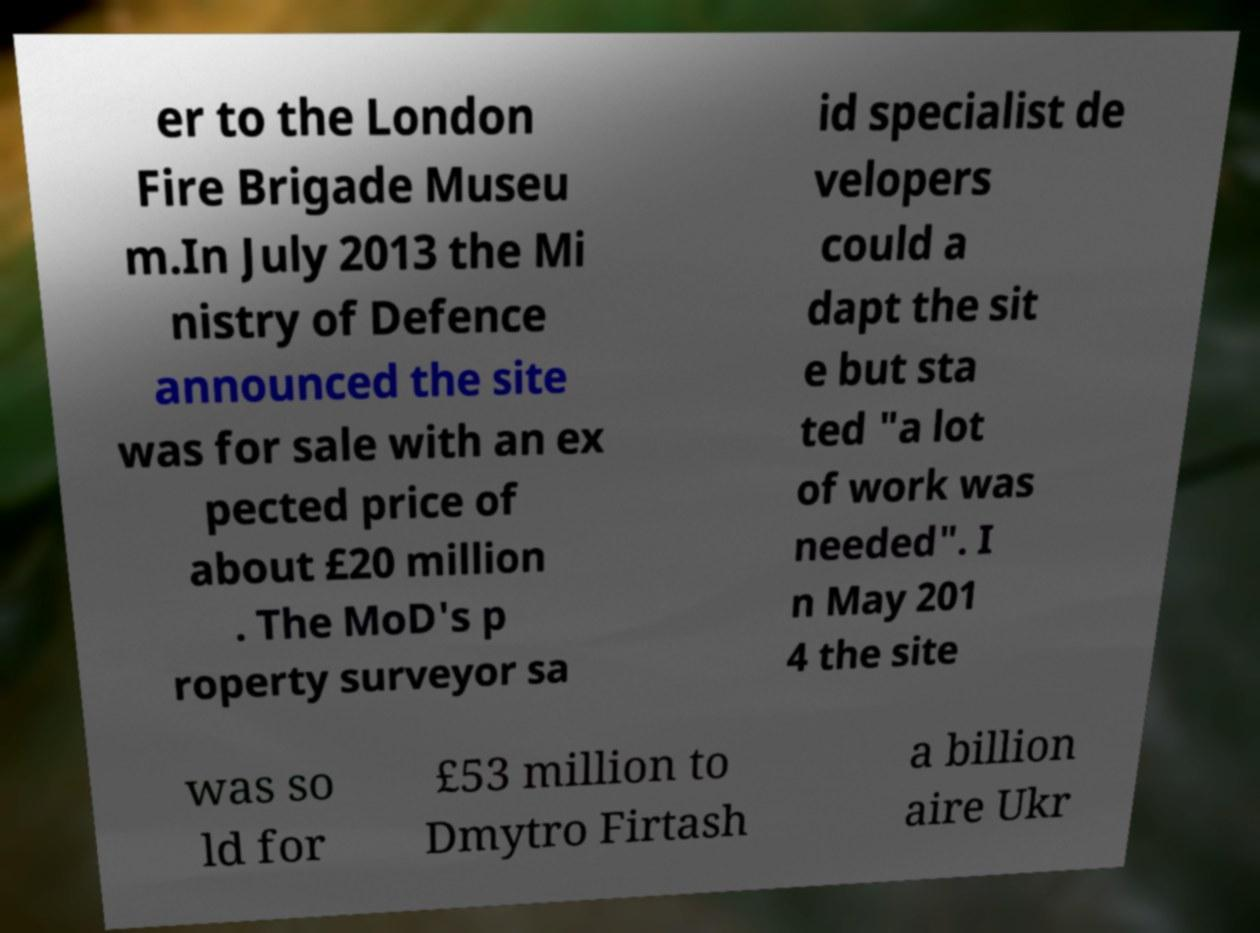What messages or text are displayed in this image? I need them in a readable, typed format. er to the London Fire Brigade Museu m.In July 2013 the Mi nistry of Defence announced the site was for sale with an ex pected price of about £20 million . The MoD's p roperty surveyor sa id specialist de velopers could a dapt the sit e but sta ted "a lot of work was needed". I n May 201 4 the site was so ld for £53 million to Dmytro Firtash a billion aire Ukr 